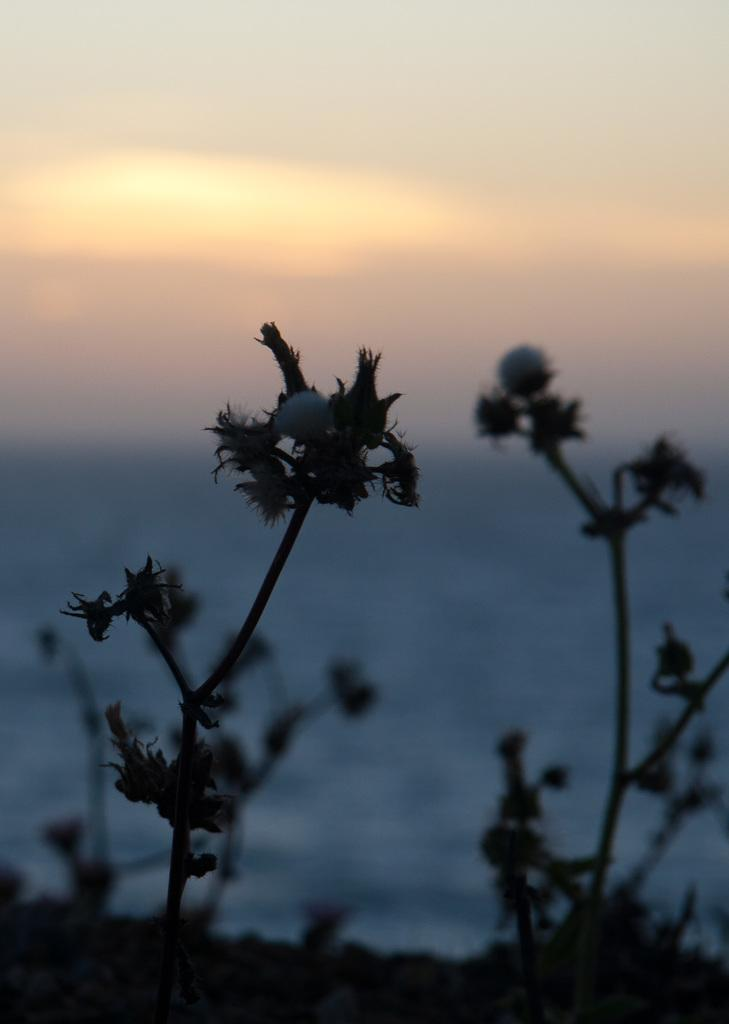What type of living organisms can be seen in the image? Plants can be seen in the image. What natural element is visible in the image? Water and the sky are visible in the image. What can be seen in the sky in the image? Clouds are present in the sky. What type of glove is being used to fuel the plants in the image? There is no glove or fuel present in the image; the plants are not being fueled. 